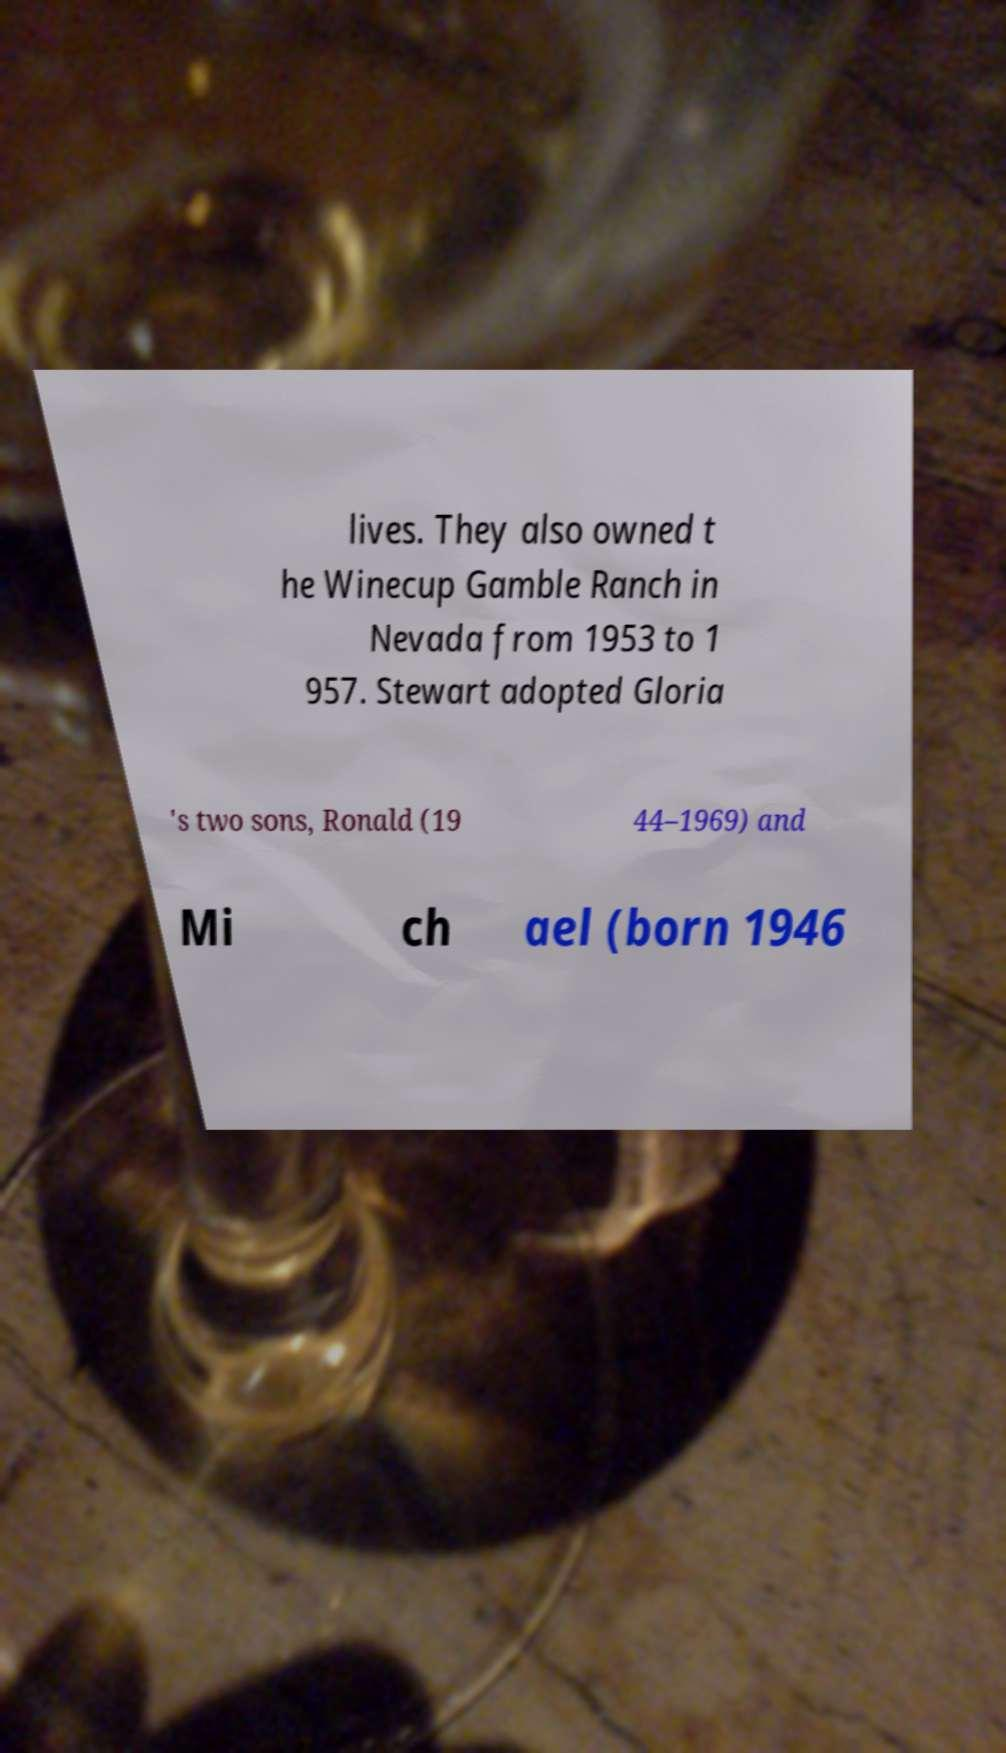Can you read and provide the text displayed in the image?This photo seems to have some interesting text. Can you extract and type it out for me? lives. They also owned t he Winecup Gamble Ranch in Nevada from 1953 to 1 957. Stewart adopted Gloria 's two sons, Ronald (19 44–1969) and Mi ch ael (born 1946 